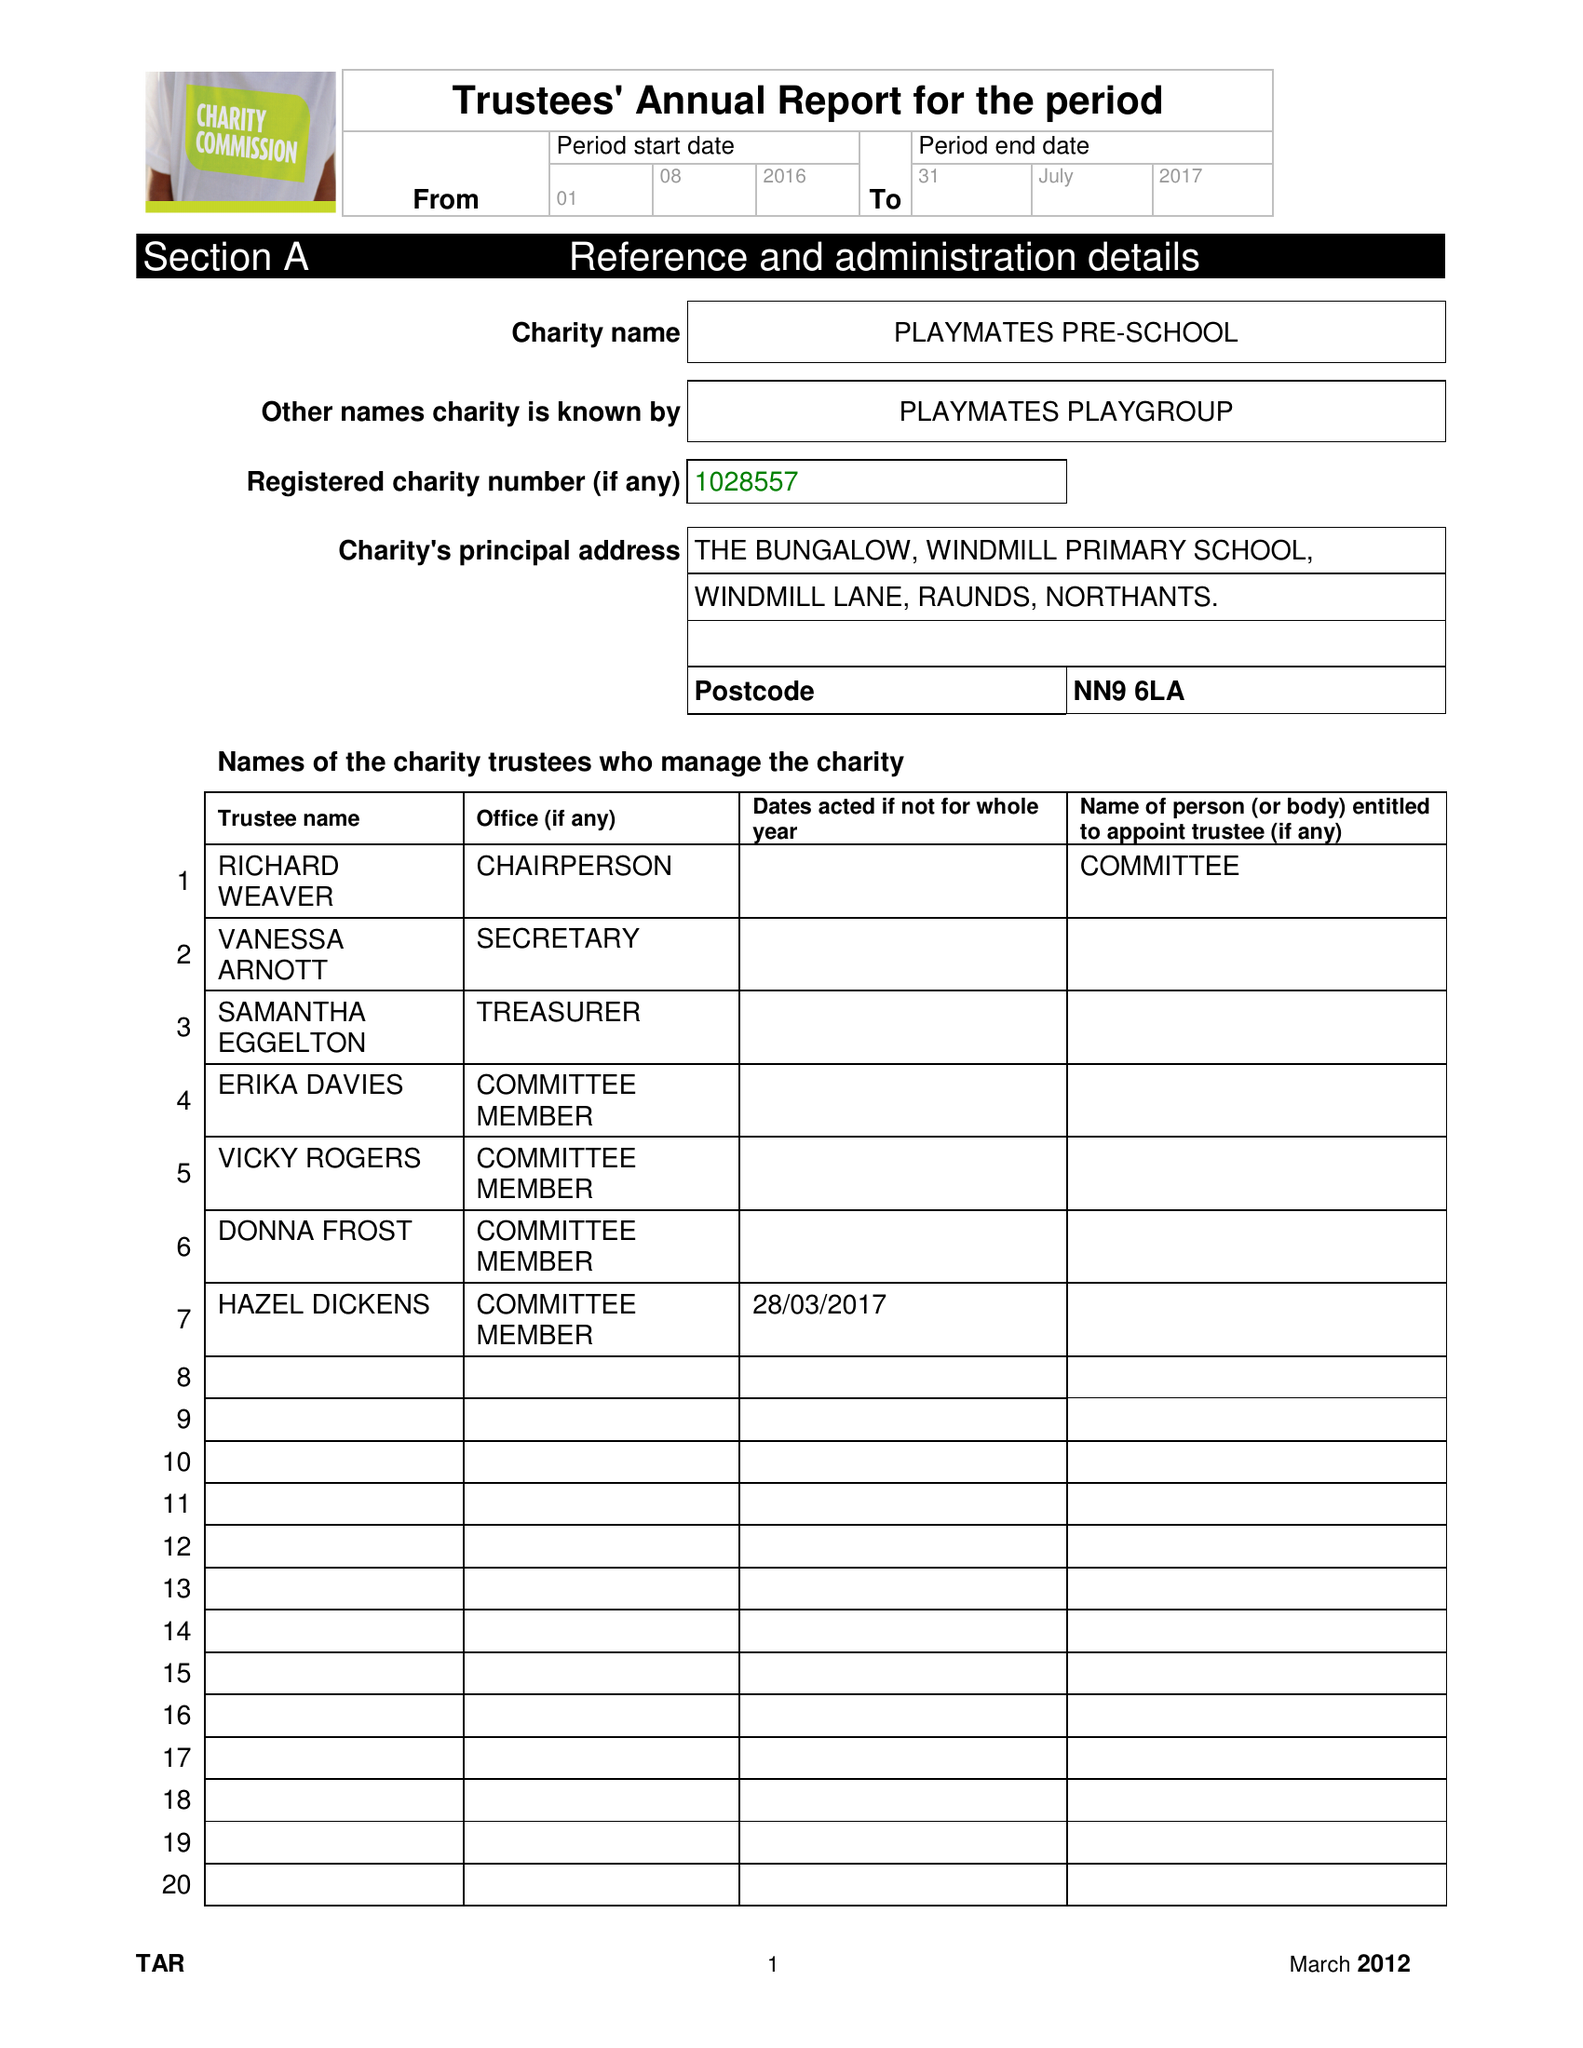What is the value for the charity_number?
Answer the question using a single word or phrase. 1028557 